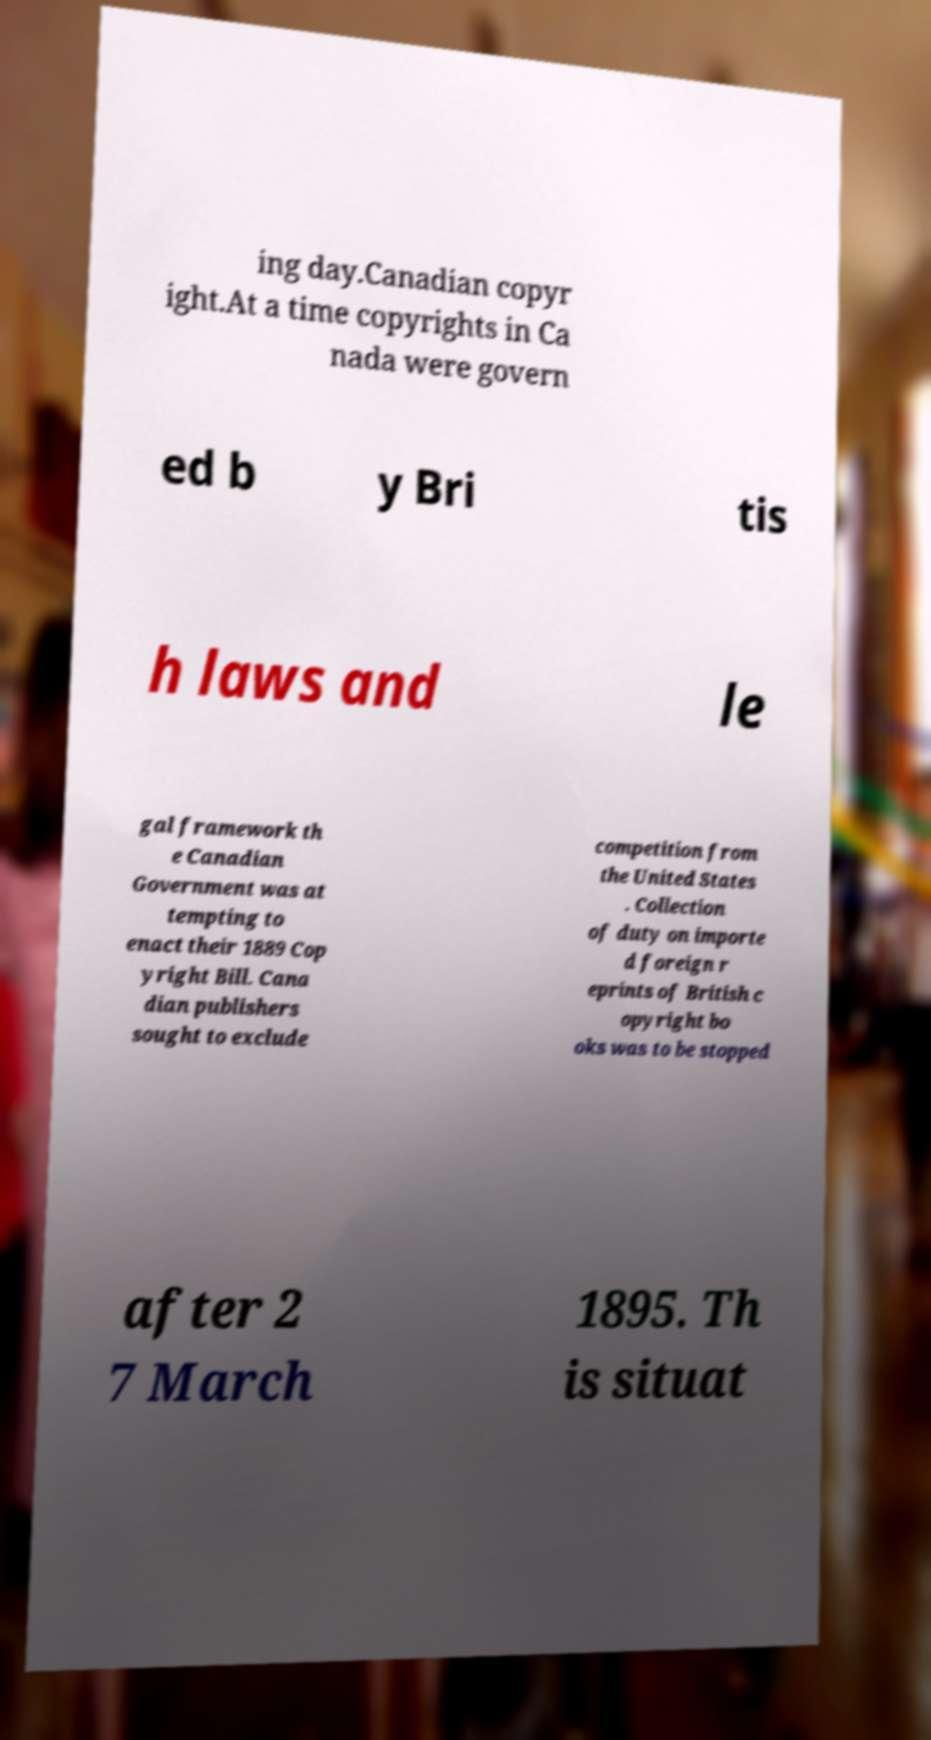Please identify and transcribe the text found in this image. ing day.Canadian copyr ight.At a time copyrights in Ca nada were govern ed b y Bri tis h laws and le gal framework th e Canadian Government was at tempting to enact their 1889 Cop yright Bill. Cana dian publishers sought to exclude competition from the United States . Collection of duty on importe d foreign r eprints of British c opyright bo oks was to be stopped after 2 7 March 1895. Th is situat 